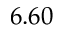Convert formula to latex. <formula><loc_0><loc_0><loc_500><loc_500>6 . 6 0</formula> 